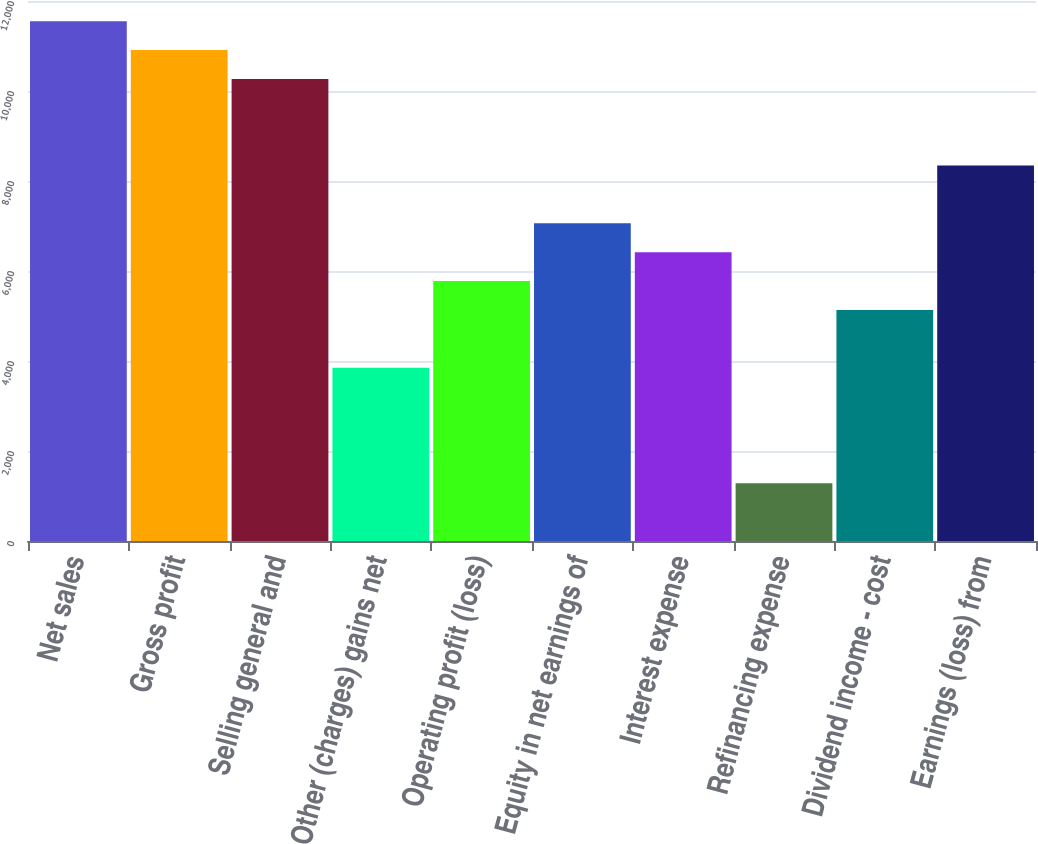Convert chart. <chart><loc_0><loc_0><loc_500><loc_500><bar_chart><fcel>Net sales<fcel>Gross profit<fcel>Selling general and<fcel>Other (charges) gains net<fcel>Operating profit (loss)<fcel>Equity in net earnings of<fcel>Interest expense<fcel>Refinancing expense<fcel>Dividend income - cost<fcel>Earnings (loss) from<nl><fcel>11550.8<fcel>10909.2<fcel>10267.6<fcel>3851.6<fcel>5776.4<fcel>7059.6<fcel>6418<fcel>1285.2<fcel>5134.8<fcel>8342.8<nl></chart> 